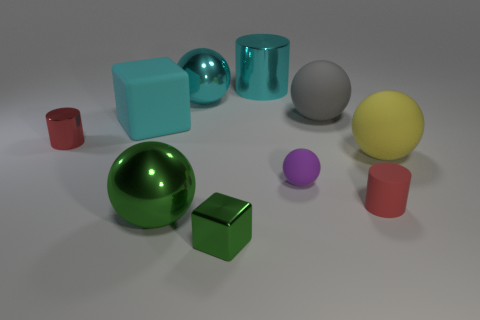Does the metallic object to the left of the green shiny ball have the same size as the matte sphere that is behind the red metal object?
Ensure brevity in your answer.  No. Do the small rubber cylinder and the tiny shiny cylinder have the same color?
Provide a short and direct response. Yes. Is there anything else that is the same shape as the yellow matte object?
Provide a succinct answer. Yes. There is a large rubber object left of the green thing to the left of the small cube; what is its shape?
Your response must be concise. Cube. What shape is the tiny purple thing that is the same material as the yellow object?
Your response must be concise. Sphere. How big is the red cylinder on the right side of the gray rubber sphere in front of the cyan shiny sphere?
Keep it short and to the point. Small. The yellow matte object has what shape?
Offer a terse response. Sphere. What number of large objects are rubber balls or red cylinders?
Provide a short and direct response. 2. There is a purple object that is the same shape as the large green shiny thing; what is its size?
Offer a terse response. Small. How many objects are both behind the red shiny object and in front of the green sphere?
Offer a very short reply. 0. 